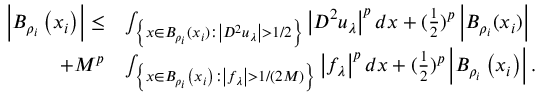Convert formula to latex. <formula><loc_0><loc_0><loc_500><loc_500>\begin{array} { r l } { \left | B _ { \rho _ { i } } \left ( x _ { i } \right ) \right | \leq } & { \int _ { \left \{ x \in B _ { \rho _ { i } } ( x _ { i } ) \colon \left | D ^ { 2 } u _ { \lambda } \right | > 1 / 2 \right \} } \left | D ^ { 2 } u _ { \lambda } \right | ^ { p } d x + ( \frac { 1 } { 2 } ) ^ { p } \left | B _ { \rho _ { i } } ( x _ { i } ) \right | } \\ { + M ^ { p } } & { \int _ { \left \{ x \in B _ { \rho _ { i } } \left ( x _ { i } \right ) \colon \left | f _ { \lambda } \right | > 1 / ( 2 M ) \right \} } \left | f _ { \lambda } \right | ^ { p } d x + ( \frac { 1 } { 2 } ) ^ { p } \left | B _ { \rho _ { i } } \left ( x _ { i } \right ) \right | . } \end{array}</formula> 